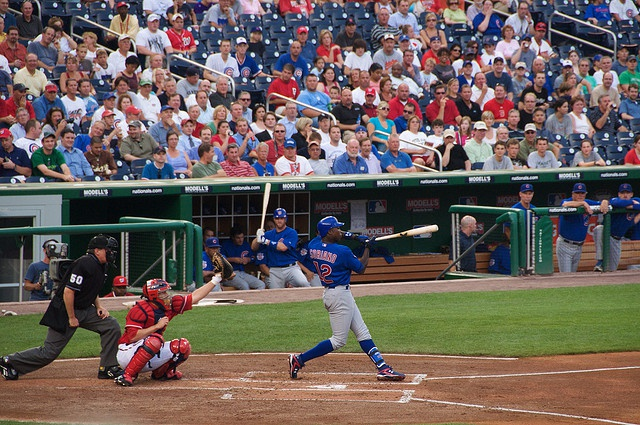Describe the objects in this image and their specific colors. I can see people in brown, black, gray, and navy tones, people in brown, darkgray, black, navy, and darkblue tones, people in brown, black, and maroon tones, people in brown, navy, darkgray, black, and darkblue tones, and bench in brown, maroon, and black tones in this image. 